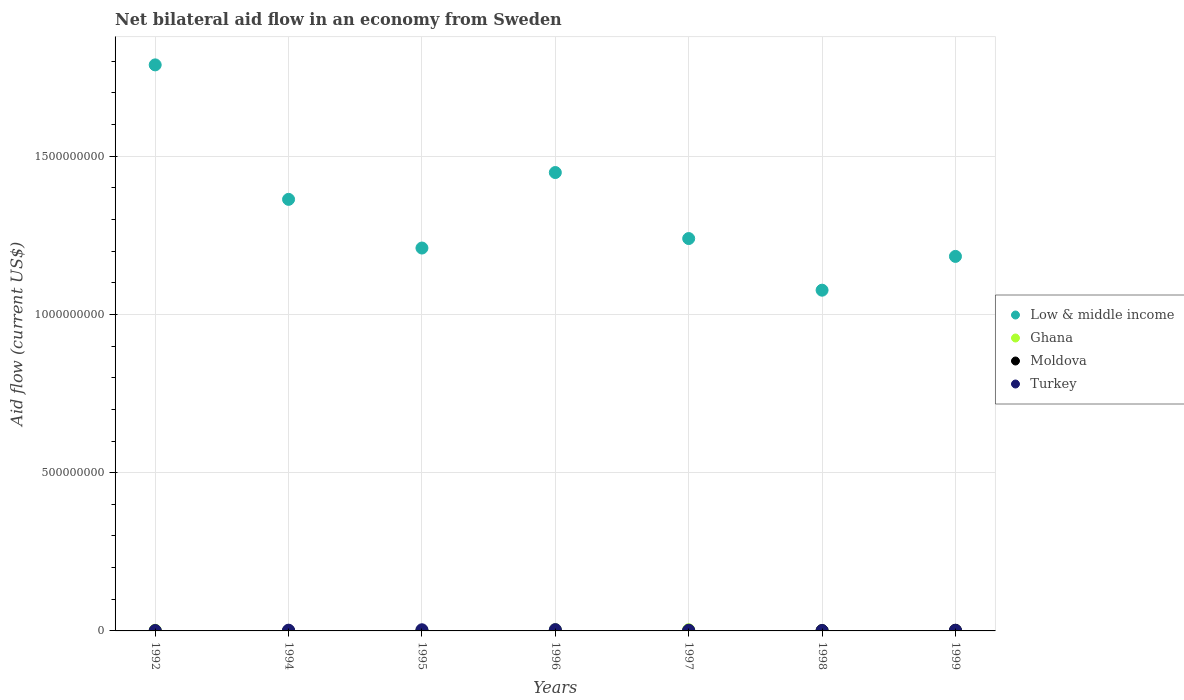How many different coloured dotlines are there?
Your response must be concise. 4. What is the net bilateral aid flow in Turkey in 1999?
Provide a succinct answer. 1.50e+06. Across all years, what is the maximum net bilateral aid flow in Moldova?
Offer a terse response. 2.19e+06. What is the total net bilateral aid flow in Moldova in the graph?
Your answer should be compact. 3.39e+06. What is the difference between the net bilateral aid flow in Turkey in 1994 and the net bilateral aid flow in Low & middle income in 1996?
Offer a terse response. -1.45e+09. What is the average net bilateral aid flow in Ghana per year?
Your answer should be very brief. 1.80e+06. In the year 1999, what is the difference between the net bilateral aid flow in Turkey and net bilateral aid flow in Low & middle income?
Your answer should be very brief. -1.18e+09. What is the ratio of the net bilateral aid flow in Turkey in 1992 to that in 1996?
Provide a succinct answer. 0.27. Is the net bilateral aid flow in Low & middle income in 1994 less than that in 1996?
Give a very brief answer. Yes. Is the difference between the net bilateral aid flow in Turkey in 1992 and 1995 greater than the difference between the net bilateral aid flow in Low & middle income in 1992 and 1995?
Ensure brevity in your answer.  No. What is the difference between the highest and the second highest net bilateral aid flow in Low & middle income?
Provide a short and direct response. 3.40e+08. What is the difference between the highest and the lowest net bilateral aid flow in Ghana?
Give a very brief answer. 3.42e+06. Is the net bilateral aid flow in Turkey strictly less than the net bilateral aid flow in Ghana over the years?
Provide a short and direct response. No. How many dotlines are there?
Make the answer very short. 4. What is the difference between two consecutive major ticks on the Y-axis?
Keep it short and to the point. 5.00e+08. Are the values on the major ticks of Y-axis written in scientific E-notation?
Your answer should be very brief. No. Does the graph contain any zero values?
Give a very brief answer. No. Does the graph contain grids?
Your answer should be very brief. Yes. How many legend labels are there?
Your response must be concise. 4. How are the legend labels stacked?
Give a very brief answer. Vertical. What is the title of the graph?
Offer a terse response. Net bilateral aid flow in an economy from Sweden. What is the Aid flow (current US$) of Low & middle income in 1992?
Make the answer very short. 1.79e+09. What is the Aid flow (current US$) in Ghana in 1992?
Your answer should be compact. 2.13e+06. What is the Aid flow (current US$) in Turkey in 1992?
Give a very brief answer. 1.15e+06. What is the Aid flow (current US$) in Low & middle income in 1994?
Keep it short and to the point. 1.36e+09. What is the Aid flow (current US$) in Ghana in 1994?
Provide a succinct answer. 4.30e+05. What is the Aid flow (current US$) in Moldova in 1994?
Ensure brevity in your answer.  10000. What is the Aid flow (current US$) of Turkey in 1994?
Ensure brevity in your answer.  2.35e+06. What is the Aid flow (current US$) in Low & middle income in 1995?
Your answer should be compact. 1.21e+09. What is the Aid flow (current US$) in Ghana in 1995?
Your answer should be very brief. 1.17e+06. What is the Aid flow (current US$) of Moldova in 1995?
Provide a succinct answer. 3.00e+04. What is the Aid flow (current US$) in Turkey in 1995?
Provide a short and direct response. 3.65e+06. What is the Aid flow (current US$) of Low & middle income in 1996?
Offer a terse response. 1.45e+09. What is the Aid flow (current US$) of Ghana in 1996?
Your answer should be compact. 3.85e+06. What is the Aid flow (current US$) in Turkey in 1996?
Your answer should be compact. 4.22e+06. What is the Aid flow (current US$) of Low & middle income in 1997?
Give a very brief answer. 1.24e+09. What is the Aid flow (current US$) in Ghana in 1997?
Keep it short and to the point. 3.76e+06. What is the Aid flow (current US$) in Moldova in 1997?
Provide a succinct answer. 9.00e+04. What is the Aid flow (current US$) in Turkey in 1997?
Your answer should be very brief. 2.24e+06. What is the Aid flow (current US$) in Low & middle income in 1998?
Your response must be concise. 1.08e+09. What is the Aid flow (current US$) in Ghana in 1998?
Ensure brevity in your answer.  6.50e+05. What is the Aid flow (current US$) of Moldova in 1998?
Keep it short and to the point. 9.60e+05. What is the Aid flow (current US$) of Turkey in 1998?
Make the answer very short. 9.50e+05. What is the Aid flow (current US$) in Low & middle income in 1999?
Your answer should be very brief. 1.18e+09. What is the Aid flow (current US$) of Ghana in 1999?
Provide a short and direct response. 5.80e+05. What is the Aid flow (current US$) in Moldova in 1999?
Provide a short and direct response. 2.19e+06. What is the Aid flow (current US$) in Turkey in 1999?
Ensure brevity in your answer.  1.50e+06. Across all years, what is the maximum Aid flow (current US$) in Low & middle income?
Your answer should be very brief. 1.79e+09. Across all years, what is the maximum Aid flow (current US$) of Ghana?
Your response must be concise. 3.85e+06. Across all years, what is the maximum Aid flow (current US$) in Moldova?
Offer a very short reply. 2.19e+06. Across all years, what is the maximum Aid flow (current US$) in Turkey?
Offer a terse response. 4.22e+06. Across all years, what is the minimum Aid flow (current US$) in Low & middle income?
Provide a succinct answer. 1.08e+09. Across all years, what is the minimum Aid flow (current US$) in Ghana?
Your answer should be very brief. 4.30e+05. Across all years, what is the minimum Aid flow (current US$) of Moldova?
Make the answer very short. 10000. Across all years, what is the minimum Aid flow (current US$) of Turkey?
Keep it short and to the point. 9.50e+05. What is the total Aid flow (current US$) of Low & middle income in the graph?
Your answer should be compact. 9.31e+09. What is the total Aid flow (current US$) in Ghana in the graph?
Offer a terse response. 1.26e+07. What is the total Aid flow (current US$) in Moldova in the graph?
Offer a terse response. 3.39e+06. What is the total Aid flow (current US$) in Turkey in the graph?
Provide a succinct answer. 1.61e+07. What is the difference between the Aid flow (current US$) in Low & middle income in 1992 and that in 1994?
Make the answer very short. 4.25e+08. What is the difference between the Aid flow (current US$) in Ghana in 1992 and that in 1994?
Ensure brevity in your answer.  1.70e+06. What is the difference between the Aid flow (current US$) in Moldova in 1992 and that in 1994?
Give a very brief answer. 9.00e+04. What is the difference between the Aid flow (current US$) of Turkey in 1992 and that in 1994?
Make the answer very short. -1.20e+06. What is the difference between the Aid flow (current US$) of Low & middle income in 1992 and that in 1995?
Your answer should be very brief. 5.79e+08. What is the difference between the Aid flow (current US$) of Ghana in 1992 and that in 1995?
Offer a terse response. 9.60e+05. What is the difference between the Aid flow (current US$) in Moldova in 1992 and that in 1995?
Provide a succinct answer. 7.00e+04. What is the difference between the Aid flow (current US$) in Turkey in 1992 and that in 1995?
Make the answer very short. -2.50e+06. What is the difference between the Aid flow (current US$) of Low & middle income in 1992 and that in 1996?
Offer a very short reply. 3.40e+08. What is the difference between the Aid flow (current US$) of Ghana in 1992 and that in 1996?
Ensure brevity in your answer.  -1.72e+06. What is the difference between the Aid flow (current US$) in Moldova in 1992 and that in 1996?
Offer a very short reply. 9.00e+04. What is the difference between the Aid flow (current US$) of Turkey in 1992 and that in 1996?
Provide a short and direct response. -3.07e+06. What is the difference between the Aid flow (current US$) in Low & middle income in 1992 and that in 1997?
Provide a short and direct response. 5.49e+08. What is the difference between the Aid flow (current US$) in Ghana in 1992 and that in 1997?
Ensure brevity in your answer.  -1.63e+06. What is the difference between the Aid flow (current US$) in Moldova in 1992 and that in 1997?
Offer a terse response. 10000. What is the difference between the Aid flow (current US$) in Turkey in 1992 and that in 1997?
Your response must be concise. -1.09e+06. What is the difference between the Aid flow (current US$) of Low & middle income in 1992 and that in 1998?
Keep it short and to the point. 7.12e+08. What is the difference between the Aid flow (current US$) in Ghana in 1992 and that in 1998?
Make the answer very short. 1.48e+06. What is the difference between the Aid flow (current US$) of Moldova in 1992 and that in 1998?
Offer a terse response. -8.60e+05. What is the difference between the Aid flow (current US$) of Turkey in 1992 and that in 1998?
Make the answer very short. 2.00e+05. What is the difference between the Aid flow (current US$) of Low & middle income in 1992 and that in 1999?
Provide a short and direct response. 6.05e+08. What is the difference between the Aid flow (current US$) in Ghana in 1992 and that in 1999?
Make the answer very short. 1.55e+06. What is the difference between the Aid flow (current US$) in Moldova in 1992 and that in 1999?
Your response must be concise. -2.09e+06. What is the difference between the Aid flow (current US$) of Turkey in 1992 and that in 1999?
Offer a terse response. -3.50e+05. What is the difference between the Aid flow (current US$) of Low & middle income in 1994 and that in 1995?
Make the answer very short. 1.54e+08. What is the difference between the Aid flow (current US$) in Ghana in 1994 and that in 1995?
Your response must be concise. -7.40e+05. What is the difference between the Aid flow (current US$) of Moldova in 1994 and that in 1995?
Give a very brief answer. -2.00e+04. What is the difference between the Aid flow (current US$) in Turkey in 1994 and that in 1995?
Provide a succinct answer. -1.30e+06. What is the difference between the Aid flow (current US$) of Low & middle income in 1994 and that in 1996?
Your answer should be compact. -8.48e+07. What is the difference between the Aid flow (current US$) in Ghana in 1994 and that in 1996?
Give a very brief answer. -3.42e+06. What is the difference between the Aid flow (current US$) in Turkey in 1994 and that in 1996?
Keep it short and to the point. -1.87e+06. What is the difference between the Aid flow (current US$) in Low & middle income in 1994 and that in 1997?
Your answer should be compact. 1.24e+08. What is the difference between the Aid flow (current US$) in Ghana in 1994 and that in 1997?
Your response must be concise. -3.33e+06. What is the difference between the Aid flow (current US$) of Turkey in 1994 and that in 1997?
Provide a short and direct response. 1.10e+05. What is the difference between the Aid flow (current US$) of Low & middle income in 1994 and that in 1998?
Provide a succinct answer. 2.87e+08. What is the difference between the Aid flow (current US$) in Ghana in 1994 and that in 1998?
Provide a short and direct response. -2.20e+05. What is the difference between the Aid flow (current US$) in Moldova in 1994 and that in 1998?
Keep it short and to the point. -9.50e+05. What is the difference between the Aid flow (current US$) of Turkey in 1994 and that in 1998?
Keep it short and to the point. 1.40e+06. What is the difference between the Aid flow (current US$) in Low & middle income in 1994 and that in 1999?
Offer a very short reply. 1.80e+08. What is the difference between the Aid flow (current US$) of Ghana in 1994 and that in 1999?
Make the answer very short. -1.50e+05. What is the difference between the Aid flow (current US$) in Moldova in 1994 and that in 1999?
Provide a succinct answer. -2.18e+06. What is the difference between the Aid flow (current US$) of Turkey in 1994 and that in 1999?
Your answer should be compact. 8.50e+05. What is the difference between the Aid flow (current US$) in Low & middle income in 1995 and that in 1996?
Give a very brief answer. -2.39e+08. What is the difference between the Aid flow (current US$) of Ghana in 1995 and that in 1996?
Give a very brief answer. -2.68e+06. What is the difference between the Aid flow (current US$) of Turkey in 1995 and that in 1996?
Your answer should be compact. -5.70e+05. What is the difference between the Aid flow (current US$) in Low & middle income in 1995 and that in 1997?
Offer a terse response. -3.00e+07. What is the difference between the Aid flow (current US$) in Ghana in 1995 and that in 1997?
Provide a short and direct response. -2.59e+06. What is the difference between the Aid flow (current US$) of Moldova in 1995 and that in 1997?
Provide a short and direct response. -6.00e+04. What is the difference between the Aid flow (current US$) of Turkey in 1995 and that in 1997?
Provide a short and direct response. 1.41e+06. What is the difference between the Aid flow (current US$) in Low & middle income in 1995 and that in 1998?
Give a very brief answer. 1.33e+08. What is the difference between the Aid flow (current US$) of Ghana in 1995 and that in 1998?
Your response must be concise. 5.20e+05. What is the difference between the Aid flow (current US$) of Moldova in 1995 and that in 1998?
Ensure brevity in your answer.  -9.30e+05. What is the difference between the Aid flow (current US$) in Turkey in 1995 and that in 1998?
Provide a short and direct response. 2.70e+06. What is the difference between the Aid flow (current US$) of Low & middle income in 1995 and that in 1999?
Ensure brevity in your answer.  2.64e+07. What is the difference between the Aid flow (current US$) in Ghana in 1995 and that in 1999?
Offer a terse response. 5.90e+05. What is the difference between the Aid flow (current US$) of Moldova in 1995 and that in 1999?
Provide a short and direct response. -2.16e+06. What is the difference between the Aid flow (current US$) of Turkey in 1995 and that in 1999?
Your response must be concise. 2.15e+06. What is the difference between the Aid flow (current US$) of Low & middle income in 1996 and that in 1997?
Keep it short and to the point. 2.09e+08. What is the difference between the Aid flow (current US$) in Turkey in 1996 and that in 1997?
Your answer should be very brief. 1.98e+06. What is the difference between the Aid flow (current US$) in Low & middle income in 1996 and that in 1998?
Ensure brevity in your answer.  3.72e+08. What is the difference between the Aid flow (current US$) of Ghana in 1996 and that in 1998?
Offer a terse response. 3.20e+06. What is the difference between the Aid flow (current US$) in Moldova in 1996 and that in 1998?
Your answer should be compact. -9.50e+05. What is the difference between the Aid flow (current US$) of Turkey in 1996 and that in 1998?
Offer a terse response. 3.27e+06. What is the difference between the Aid flow (current US$) in Low & middle income in 1996 and that in 1999?
Provide a short and direct response. 2.65e+08. What is the difference between the Aid flow (current US$) in Ghana in 1996 and that in 1999?
Keep it short and to the point. 3.27e+06. What is the difference between the Aid flow (current US$) in Moldova in 1996 and that in 1999?
Provide a short and direct response. -2.18e+06. What is the difference between the Aid flow (current US$) of Turkey in 1996 and that in 1999?
Offer a very short reply. 2.72e+06. What is the difference between the Aid flow (current US$) of Low & middle income in 1997 and that in 1998?
Offer a terse response. 1.63e+08. What is the difference between the Aid flow (current US$) in Ghana in 1997 and that in 1998?
Provide a short and direct response. 3.11e+06. What is the difference between the Aid flow (current US$) of Moldova in 1997 and that in 1998?
Offer a terse response. -8.70e+05. What is the difference between the Aid flow (current US$) in Turkey in 1997 and that in 1998?
Your answer should be compact. 1.29e+06. What is the difference between the Aid flow (current US$) of Low & middle income in 1997 and that in 1999?
Provide a short and direct response. 5.64e+07. What is the difference between the Aid flow (current US$) in Ghana in 1997 and that in 1999?
Give a very brief answer. 3.18e+06. What is the difference between the Aid flow (current US$) in Moldova in 1997 and that in 1999?
Give a very brief answer. -2.10e+06. What is the difference between the Aid flow (current US$) of Turkey in 1997 and that in 1999?
Offer a very short reply. 7.40e+05. What is the difference between the Aid flow (current US$) of Low & middle income in 1998 and that in 1999?
Keep it short and to the point. -1.07e+08. What is the difference between the Aid flow (current US$) of Ghana in 1998 and that in 1999?
Your answer should be compact. 7.00e+04. What is the difference between the Aid flow (current US$) of Moldova in 1998 and that in 1999?
Offer a very short reply. -1.23e+06. What is the difference between the Aid flow (current US$) in Turkey in 1998 and that in 1999?
Keep it short and to the point. -5.50e+05. What is the difference between the Aid flow (current US$) in Low & middle income in 1992 and the Aid flow (current US$) in Ghana in 1994?
Ensure brevity in your answer.  1.79e+09. What is the difference between the Aid flow (current US$) of Low & middle income in 1992 and the Aid flow (current US$) of Moldova in 1994?
Your response must be concise. 1.79e+09. What is the difference between the Aid flow (current US$) in Low & middle income in 1992 and the Aid flow (current US$) in Turkey in 1994?
Your answer should be compact. 1.79e+09. What is the difference between the Aid flow (current US$) in Ghana in 1992 and the Aid flow (current US$) in Moldova in 1994?
Ensure brevity in your answer.  2.12e+06. What is the difference between the Aid flow (current US$) in Moldova in 1992 and the Aid flow (current US$) in Turkey in 1994?
Give a very brief answer. -2.25e+06. What is the difference between the Aid flow (current US$) in Low & middle income in 1992 and the Aid flow (current US$) in Ghana in 1995?
Make the answer very short. 1.79e+09. What is the difference between the Aid flow (current US$) of Low & middle income in 1992 and the Aid flow (current US$) of Moldova in 1995?
Keep it short and to the point. 1.79e+09. What is the difference between the Aid flow (current US$) in Low & middle income in 1992 and the Aid flow (current US$) in Turkey in 1995?
Ensure brevity in your answer.  1.79e+09. What is the difference between the Aid flow (current US$) in Ghana in 1992 and the Aid flow (current US$) in Moldova in 1995?
Offer a terse response. 2.10e+06. What is the difference between the Aid flow (current US$) in Ghana in 1992 and the Aid flow (current US$) in Turkey in 1995?
Make the answer very short. -1.52e+06. What is the difference between the Aid flow (current US$) of Moldova in 1992 and the Aid flow (current US$) of Turkey in 1995?
Make the answer very short. -3.55e+06. What is the difference between the Aid flow (current US$) in Low & middle income in 1992 and the Aid flow (current US$) in Ghana in 1996?
Make the answer very short. 1.78e+09. What is the difference between the Aid flow (current US$) of Low & middle income in 1992 and the Aid flow (current US$) of Moldova in 1996?
Ensure brevity in your answer.  1.79e+09. What is the difference between the Aid flow (current US$) of Low & middle income in 1992 and the Aid flow (current US$) of Turkey in 1996?
Provide a short and direct response. 1.78e+09. What is the difference between the Aid flow (current US$) in Ghana in 1992 and the Aid flow (current US$) in Moldova in 1996?
Your response must be concise. 2.12e+06. What is the difference between the Aid flow (current US$) in Ghana in 1992 and the Aid flow (current US$) in Turkey in 1996?
Give a very brief answer. -2.09e+06. What is the difference between the Aid flow (current US$) in Moldova in 1992 and the Aid flow (current US$) in Turkey in 1996?
Provide a succinct answer. -4.12e+06. What is the difference between the Aid flow (current US$) of Low & middle income in 1992 and the Aid flow (current US$) of Ghana in 1997?
Your answer should be very brief. 1.79e+09. What is the difference between the Aid flow (current US$) of Low & middle income in 1992 and the Aid flow (current US$) of Moldova in 1997?
Give a very brief answer. 1.79e+09. What is the difference between the Aid flow (current US$) of Low & middle income in 1992 and the Aid flow (current US$) of Turkey in 1997?
Make the answer very short. 1.79e+09. What is the difference between the Aid flow (current US$) in Ghana in 1992 and the Aid flow (current US$) in Moldova in 1997?
Make the answer very short. 2.04e+06. What is the difference between the Aid flow (current US$) of Ghana in 1992 and the Aid flow (current US$) of Turkey in 1997?
Your answer should be very brief. -1.10e+05. What is the difference between the Aid flow (current US$) of Moldova in 1992 and the Aid flow (current US$) of Turkey in 1997?
Your answer should be compact. -2.14e+06. What is the difference between the Aid flow (current US$) in Low & middle income in 1992 and the Aid flow (current US$) in Ghana in 1998?
Your response must be concise. 1.79e+09. What is the difference between the Aid flow (current US$) in Low & middle income in 1992 and the Aid flow (current US$) in Moldova in 1998?
Provide a short and direct response. 1.79e+09. What is the difference between the Aid flow (current US$) in Low & middle income in 1992 and the Aid flow (current US$) in Turkey in 1998?
Give a very brief answer. 1.79e+09. What is the difference between the Aid flow (current US$) in Ghana in 1992 and the Aid flow (current US$) in Moldova in 1998?
Provide a short and direct response. 1.17e+06. What is the difference between the Aid flow (current US$) of Ghana in 1992 and the Aid flow (current US$) of Turkey in 1998?
Ensure brevity in your answer.  1.18e+06. What is the difference between the Aid flow (current US$) in Moldova in 1992 and the Aid flow (current US$) in Turkey in 1998?
Give a very brief answer. -8.50e+05. What is the difference between the Aid flow (current US$) in Low & middle income in 1992 and the Aid flow (current US$) in Ghana in 1999?
Offer a very short reply. 1.79e+09. What is the difference between the Aid flow (current US$) of Low & middle income in 1992 and the Aid flow (current US$) of Moldova in 1999?
Give a very brief answer. 1.79e+09. What is the difference between the Aid flow (current US$) of Low & middle income in 1992 and the Aid flow (current US$) of Turkey in 1999?
Make the answer very short. 1.79e+09. What is the difference between the Aid flow (current US$) of Ghana in 1992 and the Aid flow (current US$) of Turkey in 1999?
Offer a very short reply. 6.30e+05. What is the difference between the Aid flow (current US$) in Moldova in 1992 and the Aid flow (current US$) in Turkey in 1999?
Provide a succinct answer. -1.40e+06. What is the difference between the Aid flow (current US$) of Low & middle income in 1994 and the Aid flow (current US$) of Ghana in 1995?
Keep it short and to the point. 1.36e+09. What is the difference between the Aid flow (current US$) in Low & middle income in 1994 and the Aid flow (current US$) in Moldova in 1995?
Ensure brevity in your answer.  1.36e+09. What is the difference between the Aid flow (current US$) of Low & middle income in 1994 and the Aid flow (current US$) of Turkey in 1995?
Offer a terse response. 1.36e+09. What is the difference between the Aid flow (current US$) of Ghana in 1994 and the Aid flow (current US$) of Turkey in 1995?
Offer a terse response. -3.22e+06. What is the difference between the Aid flow (current US$) of Moldova in 1994 and the Aid flow (current US$) of Turkey in 1995?
Offer a very short reply. -3.64e+06. What is the difference between the Aid flow (current US$) of Low & middle income in 1994 and the Aid flow (current US$) of Ghana in 1996?
Provide a succinct answer. 1.36e+09. What is the difference between the Aid flow (current US$) in Low & middle income in 1994 and the Aid flow (current US$) in Moldova in 1996?
Provide a succinct answer. 1.36e+09. What is the difference between the Aid flow (current US$) of Low & middle income in 1994 and the Aid flow (current US$) of Turkey in 1996?
Your answer should be compact. 1.36e+09. What is the difference between the Aid flow (current US$) of Ghana in 1994 and the Aid flow (current US$) of Moldova in 1996?
Offer a terse response. 4.20e+05. What is the difference between the Aid flow (current US$) in Ghana in 1994 and the Aid flow (current US$) in Turkey in 1996?
Give a very brief answer. -3.79e+06. What is the difference between the Aid flow (current US$) in Moldova in 1994 and the Aid flow (current US$) in Turkey in 1996?
Give a very brief answer. -4.21e+06. What is the difference between the Aid flow (current US$) in Low & middle income in 1994 and the Aid flow (current US$) in Ghana in 1997?
Provide a succinct answer. 1.36e+09. What is the difference between the Aid flow (current US$) of Low & middle income in 1994 and the Aid flow (current US$) of Moldova in 1997?
Provide a short and direct response. 1.36e+09. What is the difference between the Aid flow (current US$) of Low & middle income in 1994 and the Aid flow (current US$) of Turkey in 1997?
Offer a very short reply. 1.36e+09. What is the difference between the Aid flow (current US$) in Ghana in 1994 and the Aid flow (current US$) in Turkey in 1997?
Offer a very short reply. -1.81e+06. What is the difference between the Aid flow (current US$) of Moldova in 1994 and the Aid flow (current US$) of Turkey in 1997?
Give a very brief answer. -2.23e+06. What is the difference between the Aid flow (current US$) of Low & middle income in 1994 and the Aid flow (current US$) of Ghana in 1998?
Offer a terse response. 1.36e+09. What is the difference between the Aid flow (current US$) in Low & middle income in 1994 and the Aid flow (current US$) in Moldova in 1998?
Make the answer very short. 1.36e+09. What is the difference between the Aid flow (current US$) of Low & middle income in 1994 and the Aid flow (current US$) of Turkey in 1998?
Offer a terse response. 1.36e+09. What is the difference between the Aid flow (current US$) in Ghana in 1994 and the Aid flow (current US$) in Moldova in 1998?
Your answer should be compact. -5.30e+05. What is the difference between the Aid flow (current US$) of Ghana in 1994 and the Aid flow (current US$) of Turkey in 1998?
Provide a short and direct response. -5.20e+05. What is the difference between the Aid flow (current US$) in Moldova in 1994 and the Aid flow (current US$) in Turkey in 1998?
Provide a succinct answer. -9.40e+05. What is the difference between the Aid flow (current US$) of Low & middle income in 1994 and the Aid flow (current US$) of Ghana in 1999?
Ensure brevity in your answer.  1.36e+09. What is the difference between the Aid flow (current US$) of Low & middle income in 1994 and the Aid flow (current US$) of Moldova in 1999?
Your response must be concise. 1.36e+09. What is the difference between the Aid flow (current US$) of Low & middle income in 1994 and the Aid flow (current US$) of Turkey in 1999?
Offer a very short reply. 1.36e+09. What is the difference between the Aid flow (current US$) of Ghana in 1994 and the Aid flow (current US$) of Moldova in 1999?
Ensure brevity in your answer.  -1.76e+06. What is the difference between the Aid flow (current US$) in Ghana in 1994 and the Aid flow (current US$) in Turkey in 1999?
Ensure brevity in your answer.  -1.07e+06. What is the difference between the Aid flow (current US$) of Moldova in 1994 and the Aid flow (current US$) of Turkey in 1999?
Your answer should be compact. -1.49e+06. What is the difference between the Aid flow (current US$) in Low & middle income in 1995 and the Aid flow (current US$) in Ghana in 1996?
Give a very brief answer. 1.21e+09. What is the difference between the Aid flow (current US$) in Low & middle income in 1995 and the Aid flow (current US$) in Moldova in 1996?
Offer a terse response. 1.21e+09. What is the difference between the Aid flow (current US$) of Low & middle income in 1995 and the Aid flow (current US$) of Turkey in 1996?
Give a very brief answer. 1.21e+09. What is the difference between the Aid flow (current US$) of Ghana in 1995 and the Aid flow (current US$) of Moldova in 1996?
Keep it short and to the point. 1.16e+06. What is the difference between the Aid flow (current US$) of Ghana in 1995 and the Aid flow (current US$) of Turkey in 1996?
Provide a succinct answer. -3.05e+06. What is the difference between the Aid flow (current US$) of Moldova in 1995 and the Aid flow (current US$) of Turkey in 1996?
Your response must be concise. -4.19e+06. What is the difference between the Aid flow (current US$) of Low & middle income in 1995 and the Aid flow (current US$) of Ghana in 1997?
Your answer should be compact. 1.21e+09. What is the difference between the Aid flow (current US$) of Low & middle income in 1995 and the Aid flow (current US$) of Moldova in 1997?
Make the answer very short. 1.21e+09. What is the difference between the Aid flow (current US$) of Low & middle income in 1995 and the Aid flow (current US$) of Turkey in 1997?
Your response must be concise. 1.21e+09. What is the difference between the Aid flow (current US$) in Ghana in 1995 and the Aid flow (current US$) in Moldova in 1997?
Offer a terse response. 1.08e+06. What is the difference between the Aid flow (current US$) in Ghana in 1995 and the Aid flow (current US$) in Turkey in 1997?
Make the answer very short. -1.07e+06. What is the difference between the Aid flow (current US$) of Moldova in 1995 and the Aid flow (current US$) of Turkey in 1997?
Provide a short and direct response. -2.21e+06. What is the difference between the Aid flow (current US$) of Low & middle income in 1995 and the Aid flow (current US$) of Ghana in 1998?
Ensure brevity in your answer.  1.21e+09. What is the difference between the Aid flow (current US$) of Low & middle income in 1995 and the Aid flow (current US$) of Moldova in 1998?
Give a very brief answer. 1.21e+09. What is the difference between the Aid flow (current US$) of Low & middle income in 1995 and the Aid flow (current US$) of Turkey in 1998?
Your answer should be very brief. 1.21e+09. What is the difference between the Aid flow (current US$) of Ghana in 1995 and the Aid flow (current US$) of Moldova in 1998?
Offer a very short reply. 2.10e+05. What is the difference between the Aid flow (current US$) in Ghana in 1995 and the Aid flow (current US$) in Turkey in 1998?
Provide a short and direct response. 2.20e+05. What is the difference between the Aid flow (current US$) of Moldova in 1995 and the Aid flow (current US$) of Turkey in 1998?
Offer a terse response. -9.20e+05. What is the difference between the Aid flow (current US$) of Low & middle income in 1995 and the Aid flow (current US$) of Ghana in 1999?
Your answer should be very brief. 1.21e+09. What is the difference between the Aid flow (current US$) of Low & middle income in 1995 and the Aid flow (current US$) of Moldova in 1999?
Your answer should be very brief. 1.21e+09. What is the difference between the Aid flow (current US$) of Low & middle income in 1995 and the Aid flow (current US$) of Turkey in 1999?
Your answer should be compact. 1.21e+09. What is the difference between the Aid flow (current US$) of Ghana in 1995 and the Aid flow (current US$) of Moldova in 1999?
Ensure brevity in your answer.  -1.02e+06. What is the difference between the Aid flow (current US$) in Ghana in 1995 and the Aid flow (current US$) in Turkey in 1999?
Offer a terse response. -3.30e+05. What is the difference between the Aid flow (current US$) in Moldova in 1995 and the Aid flow (current US$) in Turkey in 1999?
Make the answer very short. -1.47e+06. What is the difference between the Aid flow (current US$) in Low & middle income in 1996 and the Aid flow (current US$) in Ghana in 1997?
Keep it short and to the point. 1.44e+09. What is the difference between the Aid flow (current US$) in Low & middle income in 1996 and the Aid flow (current US$) in Moldova in 1997?
Give a very brief answer. 1.45e+09. What is the difference between the Aid flow (current US$) of Low & middle income in 1996 and the Aid flow (current US$) of Turkey in 1997?
Your answer should be compact. 1.45e+09. What is the difference between the Aid flow (current US$) of Ghana in 1996 and the Aid flow (current US$) of Moldova in 1997?
Make the answer very short. 3.76e+06. What is the difference between the Aid flow (current US$) in Ghana in 1996 and the Aid flow (current US$) in Turkey in 1997?
Provide a short and direct response. 1.61e+06. What is the difference between the Aid flow (current US$) of Moldova in 1996 and the Aid flow (current US$) of Turkey in 1997?
Give a very brief answer. -2.23e+06. What is the difference between the Aid flow (current US$) in Low & middle income in 1996 and the Aid flow (current US$) in Ghana in 1998?
Keep it short and to the point. 1.45e+09. What is the difference between the Aid flow (current US$) in Low & middle income in 1996 and the Aid flow (current US$) in Moldova in 1998?
Offer a very short reply. 1.45e+09. What is the difference between the Aid flow (current US$) of Low & middle income in 1996 and the Aid flow (current US$) of Turkey in 1998?
Make the answer very short. 1.45e+09. What is the difference between the Aid flow (current US$) in Ghana in 1996 and the Aid flow (current US$) in Moldova in 1998?
Make the answer very short. 2.89e+06. What is the difference between the Aid flow (current US$) of Ghana in 1996 and the Aid flow (current US$) of Turkey in 1998?
Provide a succinct answer. 2.90e+06. What is the difference between the Aid flow (current US$) in Moldova in 1996 and the Aid flow (current US$) in Turkey in 1998?
Offer a very short reply. -9.40e+05. What is the difference between the Aid flow (current US$) in Low & middle income in 1996 and the Aid flow (current US$) in Ghana in 1999?
Make the answer very short. 1.45e+09. What is the difference between the Aid flow (current US$) of Low & middle income in 1996 and the Aid flow (current US$) of Moldova in 1999?
Your answer should be compact. 1.45e+09. What is the difference between the Aid flow (current US$) in Low & middle income in 1996 and the Aid flow (current US$) in Turkey in 1999?
Keep it short and to the point. 1.45e+09. What is the difference between the Aid flow (current US$) of Ghana in 1996 and the Aid flow (current US$) of Moldova in 1999?
Keep it short and to the point. 1.66e+06. What is the difference between the Aid flow (current US$) in Ghana in 1996 and the Aid flow (current US$) in Turkey in 1999?
Provide a short and direct response. 2.35e+06. What is the difference between the Aid flow (current US$) in Moldova in 1996 and the Aid flow (current US$) in Turkey in 1999?
Give a very brief answer. -1.49e+06. What is the difference between the Aid flow (current US$) in Low & middle income in 1997 and the Aid flow (current US$) in Ghana in 1998?
Your answer should be compact. 1.24e+09. What is the difference between the Aid flow (current US$) of Low & middle income in 1997 and the Aid flow (current US$) of Moldova in 1998?
Your answer should be very brief. 1.24e+09. What is the difference between the Aid flow (current US$) of Low & middle income in 1997 and the Aid flow (current US$) of Turkey in 1998?
Ensure brevity in your answer.  1.24e+09. What is the difference between the Aid flow (current US$) of Ghana in 1997 and the Aid flow (current US$) of Moldova in 1998?
Keep it short and to the point. 2.80e+06. What is the difference between the Aid flow (current US$) of Ghana in 1997 and the Aid flow (current US$) of Turkey in 1998?
Your response must be concise. 2.81e+06. What is the difference between the Aid flow (current US$) of Moldova in 1997 and the Aid flow (current US$) of Turkey in 1998?
Provide a succinct answer. -8.60e+05. What is the difference between the Aid flow (current US$) in Low & middle income in 1997 and the Aid flow (current US$) in Ghana in 1999?
Provide a short and direct response. 1.24e+09. What is the difference between the Aid flow (current US$) in Low & middle income in 1997 and the Aid flow (current US$) in Moldova in 1999?
Keep it short and to the point. 1.24e+09. What is the difference between the Aid flow (current US$) of Low & middle income in 1997 and the Aid flow (current US$) of Turkey in 1999?
Your answer should be very brief. 1.24e+09. What is the difference between the Aid flow (current US$) in Ghana in 1997 and the Aid flow (current US$) in Moldova in 1999?
Offer a terse response. 1.57e+06. What is the difference between the Aid flow (current US$) in Ghana in 1997 and the Aid flow (current US$) in Turkey in 1999?
Provide a short and direct response. 2.26e+06. What is the difference between the Aid flow (current US$) of Moldova in 1997 and the Aid flow (current US$) of Turkey in 1999?
Provide a short and direct response. -1.41e+06. What is the difference between the Aid flow (current US$) of Low & middle income in 1998 and the Aid flow (current US$) of Ghana in 1999?
Provide a succinct answer. 1.08e+09. What is the difference between the Aid flow (current US$) in Low & middle income in 1998 and the Aid flow (current US$) in Moldova in 1999?
Your response must be concise. 1.07e+09. What is the difference between the Aid flow (current US$) of Low & middle income in 1998 and the Aid flow (current US$) of Turkey in 1999?
Make the answer very short. 1.08e+09. What is the difference between the Aid flow (current US$) in Ghana in 1998 and the Aid flow (current US$) in Moldova in 1999?
Your answer should be compact. -1.54e+06. What is the difference between the Aid flow (current US$) in Ghana in 1998 and the Aid flow (current US$) in Turkey in 1999?
Make the answer very short. -8.50e+05. What is the difference between the Aid flow (current US$) of Moldova in 1998 and the Aid flow (current US$) of Turkey in 1999?
Your answer should be compact. -5.40e+05. What is the average Aid flow (current US$) in Low & middle income per year?
Your response must be concise. 1.33e+09. What is the average Aid flow (current US$) in Ghana per year?
Provide a succinct answer. 1.80e+06. What is the average Aid flow (current US$) of Moldova per year?
Your answer should be compact. 4.84e+05. What is the average Aid flow (current US$) of Turkey per year?
Your answer should be compact. 2.29e+06. In the year 1992, what is the difference between the Aid flow (current US$) in Low & middle income and Aid flow (current US$) in Ghana?
Your answer should be compact. 1.79e+09. In the year 1992, what is the difference between the Aid flow (current US$) of Low & middle income and Aid flow (current US$) of Moldova?
Ensure brevity in your answer.  1.79e+09. In the year 1992, what is the difference between the Aid flow (current US$) in Low & middle income and Aid flow (current US$) in Turkey?
Give a very brief answer. 1.79e+09. In the year 1992, what is the difference between the Aid flow (current US$) of Ghana and Aid flow (current US$) of Moldova?
Your response must be concise. 2.03e+06. In the year 1992, what is the difference between the Aid flow (current US$) of Ghana and Aid flow (current US$) of Turkey?
Provide a succinct answer. 9.80e+05. In the year 1992, what is the difference between the Aid flow (current US$) of Moldova and Aid flow (current US$) of Turkey?
Your response must be concise. -1.05e+06. In the year 1994, what is the difference between the Aid flow (current US$) of Low & middle income and Aid flow (current US$) of Ghana?
Your answer should be very brief. 1.36e+09. In the year 1994, what is the difference between the Aid flow (current US$) of Low & middle income and Aid flow (current US$) of Moldova?
Your response must be concise. 1.36e+09. In the year 1994, what is the difference between the Aid flow (current US$) of Low & middle income and Aid flow (current US$) of Turkey?
Provide a short and direct response. 1.36e+09. In the year 1994, what is the difference between the Aid flow (current US$) in Ghana and Aid flow (current US$) in Turkey?
Make the answer very short. -1.92e+06. In the year 1994, what is the difference between the Aid flow (current US$) of Moldova and Aid flow (current US$) of Turkey?
Give a very brief answer. -2.34e+06. In the year 1995, what is the difference between the Aid flow (current US$) of Low & middle income and Aid flow (current US$) of Ghana?
Your answer should be compact. 1.21e+09. In the year 1995, what is the difference between the Aid flow (current US$) of Low & middle income and Aid flow (current US$) of Moldova?
Ensure brevity in your answer.  1.21e+09. In the year 1995, what is the difference between the Aid flow (current US$) of Low & middle income and Aid flow (current US$) of Turkey?
Make the answer very short. 1.21e+09. In the year 1995, what is the difference between the Aid flow (current US$) in Ghana and Aid flow (current US$) in Moldova?
Provide a succinct answer. 1.14e+06. In the year 1995, what is the difference between the Aid flow (current US$) in Ghana and Aid flow (current US$) in Turkey?
Ensure brevity in your answer.  -2.48e+06. In the year 1995, what is the difference between the Aid flow (current US$) in Moldova and Aid flow (current US$) in Turkey?
Your answer should be compact. -3.62e+06. In the year 1996, what is the difference between the Aid flow (current US$) in Low & middle income and Aid flow (current US$) in Ghana?
Provide a succinct answer. 1.44e+09. In the year 1996, what is the difference between the Aid flow (current US$) in Low & middle income and Aid flow (current US$) in Moldova?
Offer a very short reply. 1.45e+09. In the year 1996, what is the difference between the Aid flow (current US$) of Low & middle income and Aid flow (current US$) of Turkey?
Your answer should be compact. 1.44e+09. In the year 1996, what is the difference between the Aid flow (current US$) of Ghana and Aid flow (current US$) of Moldova?
Keep it short and to the point. 3.84e+06. In the year 1996, what is the difference between the Aid flow (current US$) in Ghana and Aid flow (current US$) in Turkey?
Your answer should be compact. -3.70e+05. In the year 1996, what is the difference between the Aid flow (current US$) in Moldova and Aid flow (current US$) in Turkey?
Your answer should be compact. -4.21e+06. In the year 1997, what is the difference between the Aid flow (current US$) of Low & middle income and Aid flow (current US$) of Ghana?
Give a very brief answer. 1.24e+09. In the year 1997, what is the difference between the Aid flow (current US$) of Low & middle income and Aid flow (current US$) of Moldova?
Provide a succinct answer. 1.24e+09. In the year 1997, what is the difference between the Aid flow (current US$) of Low & middle income and Aid flow (current US$) of Turkey?
Offer a very short reply. 1.24e+09. In the year 1997, what is the difference between the Aid flow (current US$) in Ghana and Aid flow (current US$) in Moldova?
Your answer should be very brief. 3.67e+06. In the year 1997, what is the difference between the Aid flow (current US$) in Ghana and Aid flow (current US$) in Turkey?
Offer a very short reply. 1.52e+06. In the year 1997, what is the difference between the Aid flow (current US$) in Moldova and Aid flow (current US$) in Turkey?
Make the answer very short. -2.15e+06. In the year 1998, what is the difference between the Aid flow (current US$) of Low & middle income and Aid flow (current US$) of Ghana?
Your answer should be compact. 1.08e+09. In the year 1998, what is the difference between the Aid flow (current US$) of Low & middle income and Aid flow (current US$) of Moldova?
Provide a short and direct response. 1.08e+09. In the year 1998, what is the difference between the Aid flow (current US$) of Low & middle income and Aid flow (current US$) of Turkey?
Your answer should be compact. 1.08e+09. In the year 1998, what is the difference between the Aid flow (current US$) of Ghana and Aid flow (current US$) of Moldova?
Provide a short and direct response. -3.10e+05. In the year 1998, what is the difference between the Aid flow (current US$) in Ghana and Aid flow (current US$) in Turkey?
Ensure brevity in your answer.  -3.00e+05. In the year 1999, what is the difference between the Aid flow (current US$) of Low & middle income and Aid flow (current US$) of Ghana?
Ensure brevity in your answer.  1.18e+09. In the year 1999, what is the difference between the Aid flow (current US$) in Low & middle income and Aid flow (current US$) in Moldova?
Make the answer very short. 1.18e+09. In the year 1999, what is the difference between the Aid flow (current US$) of Low & middle income and Aid flow (current US$) of Turkey?
Your answer should be very brief. 1.18e+09. In the year 1999, what is the difference between the Aid flow (current US$) in Ghana and Aid flow (current US$) in Moldova?
Keep it short and to the point. -1.61e+06. In the year 1999, what is the difference between the Aid flow (current US$) in Ghana and Aid flow (current US$) in Turkey?
Provide a succinct answer. -9.20e+05. In the year 1999, what is the difference between the Aid flow (current US$) of Moldova and Aid flow (current US$) of Turkey?
Offer a terse response. 6.90e+05. What is the ratio of the Aid flow (current US$) of Low & middle income in 1992 to that in 1994?
Provide a short and direct response. 1.31. What is the ratio of the Aid flow (current US$) of Ghana in 1992 to that in 1994?
Give a very brief answer. 4.95. What is the ratio of the Aid flow (current US$) of Turkey in 1992 to that in 1994?
Make the answer very short. 0.49. What is the ratio of the Aid flow (current US$) of Low & middle income in 1992 to that in 1995?
Offer a terse response. 1.48. What is the ratio of the Aid flow (current US$) in Ghana in 1992 to that in 1995?
Offer a terse response. 1.82. What is the ratio of the Aid flow (current US$) of Moldova in 1992 to that in 1995?
Make the answer very short. 3.33. What is the ratio of the Aid flow (current US$) of Turkey in 1992 to that in 1995?
Your answer should be very brief. 0.32. What is the ratio of the Aid flow (current US$) in Low & middle income in 1992 to that in 1996?
Provide a succinct answer. 1.23. What is the ratio of the Aid flow (current US$) in Ghana in 1992 to that in 1996?
Offer a terse response. 0.55. What is the ratio of the Aid flow (current US$) of Moldova in 1992 to that in 1996?
Offer a very short reply. 10. What is the ratio of the Aid flow (current US$) of Turkey in 1992 to that in 1996?
Keep it short and to the point. 0.27. What is the ratio of the Aid flow (current US$) of Low & middle income in 1992 to that in 1997?
Provide a short and direct response. 1.44. What is the ratio of the Aid flow (current US$) of Ghana in 1992 to that in 1997?
Your answer should be compact. 0.57. What is the ratio of the Aid flow (current US$) of Turkey in 1992 to that in 1997?
Give a very brief answer. 0.51. What is the ratio of the Aid flow (current US$) of Low & middle income in 1992 to that in 1998?
Provide a succinct answer. 1.66. What is the ratio of the Aid flow (current US$) of Ghana in 1992 to that in 1998?
Your answer should be compact. 3.28. What is the ratio of the Aid flow (current US$) in Moldova in 1992 to that in 1998?
Make the answer very short. 0.1. What is the ratio of the Aid flow (current US$) in Turkey in 1992 to that in 1998?
Provide a succinct answer. 1.21. What is the ratio of the Aid flow (current US$) in Low & middle income in 1992 to that in 1999?
Ensure brevity in your answer.  1.51. What is the ratio of the Aid flow (current US$) in Ghana in 1992 to that in 1999?
Your response must be concise. 3.67. What is the ratio of the Aid flow (current US$) of Moldova in 1992 to that in 1999?
Your response must be concise. 0.05. What is the ratio of the Aid flow (current US$) in Turkey in 1992 to that in 1999?
Your answer should be compact. 0.77. What is the ratio of the Aid flow (current US$) of Low & middle income in 1994 to that in 1995?
Offer a very short reply. 1.13. What is the ratio of the Aid flow (current US$) in Ghana in 1994 to that in 1995?
Your answer should be compact. 0.37. What is the ratio of the Aid flow (current US$) of Moldova in 1994 to that in 1995?
Your answer should be very brief. 0.33. What is the ratio of the Aid flow (current US$) in Turkey in 1994 to that in 1995?
Provide a succinct answer. 0.64. What is the ratio of the Aid flow (current US$) in Low & middle income in 1994 to that in 1996?
Provide a short and direct response. 0.94. What is the ratio of the Aid flow (current US$) in Ghana in 1994 to that in 1996?
Make the answer very short. 0.11. What is the ratio of the Aid flow (current US$) of Moldova in 1994 to that in 1996?
Provide a succinct answer. 1. What is the ratio of the Aid flow (current US$) in Turkey in 1994 to that in 1996?
Give a very brief answer. 0.56. What is the ratio of the Aid flow (current US$) in Low & middle income in 1994 to that in 1997?
Your response must be concise. 1.1. What is the ratio of the Aid flow (current US$) in Ghana in 1994 to that in 1997?
Offer a terse response. 0.11. What is the ratio of the Aid flow (current US$) of Turkey in 1994 to that in 1997?
Offer a terse response. 1.05. What is the ratio of the Aid flow (current US$) in Low & middle income in 1994 to that in 1998?
Keep it short and to the point. 1.27. What is the ratio of the Aid flow (current US$) of Ghana in 1994 to that in 1998?
Give a very brief answer. 0.66. What is the ratio of the Aid flow (current US$) in Moldova in 1994 to that in 1998?
Provide a short and direct response. 0.01. What is the ratio of the Aid flow (current US$) in Turkey in 1994 to that in 1998?
Your answer should be very brief. 2.47. What is the ratio of the Aid flow (current US$) in Low & middle income in 1994 to that in 1999?
Your answer should be very brief. 1.15. What is the ratio of the Aid flow (current US$) in Ghana in 1994 to that in 1999?
Your answer should be compact. 0.74. What is the ratio of the Aid flow (current US$) in Moldova in 1994 to that in 1999?
Your answer should be very brief. 0. What is the ratio of the Aid flow (current US$) in Turkey in 1994 to that in 1999?
Keep it short and to the point. 1.57. What is the ratio of the Aid flow (current US$) of Low & middle income in 1995 to that in 1996?
Ensure brevity in your answer.  0.84. What is the ratio of the Aid flow (current US$) in Ghana in 1995 to that in 1996?
Provide a succinct answer. 0.3. What is the ratio of the Aid flow (current US$) in Turkey in 1995 to that in 1996?
Make the answer very short. 0.86. What is the ratio of the Aid flow (current US$) of Low & middle income in 1995 to that in 1997?
Offer a very short reply. 0.98. What is the ratio of the Aid flow (current US$) of Ghana in 1995 to that in 1997?
Offer a very short reply. 0.31. What is the ratio of the Aid flow (current US$) in Turkey in 1995 to that in 1997?
Ensure brevity in your answer.  1.63. What is the ratio of the Aid flow (current US$) of Low & middle income in 1995 to that in 1998?
Provide a short and direct response. 1.12. What is the ratio of the Aid flow (current US$) of Moldova in 1995 to that in 1998?
Your answer should be compact. 0.03. What is the ratio of the Aid flow (current US$) of Turkey in 1995 to that in 1998?
Provide a succinct answer. 3.84. What is the ratio of the Aid flow (current US$) of Low & middle income in 1995 to that in 1999?
Provide a short and direct response. 1.02. What is the ratio of the Aid flow (current US$) in Ghana in 1995 to that in 1999?
Provide a short and direct response. 2.02. What is the ratio of the Aid flow (current US$) in Moldova in 1995 to that in 1999?
Provide a succinct answer. 0.01. What is the ratio of the Aid flow (current US$) of Turkey in 1995 to that in 1999?
Offer a very short reply. 2.43. What is the ratio of the Aid flow (current US$) in Low & middle income in 1996 to that in 1997?
Ensure brevity in your answer.  1.17. What is the ratio of the Aid flow (current US$) of Ghana in 1996 to that in 1997?
Provide a short and direct response. 1.02. What is the ratio of the Aid flow (current US$) in Turkey in 1996 to that in 1997?
Your answer should be compact. 1.88. What is the ratio of the Aid flow (current US$) of Low & middle income in 1996 to that in 1998?
Offer a terse response. 1.35. What is the ratio of the Aid flow (current US$) in Ghana in 1996 to that in 1998?
Your answer should be compact. 5.92. What is the ratio of the Aid flow (current US$) in Moldova in 1996 to that in 1998?
Your response must be concise. 0.01. What is the ratio of the Aid flow (current US$) in Turkey in 1996 to that in 1998?
Your answer should be compact. 4.44. What is the ratio of the Aid flow (current US$) of Low & middle income in 1996 to that in 1999?
Your answer should be very brief. 1.22. What is the ratio of the Aid flow (current US$) in Ghana in 1996 to that in 1999?
Give a very brief answer. 6.64. What is the ratio of the Aid flow (current US$) in Moldova in 1996 to that in 1999?
Give a very brief answer. 0. What is the ratio of the Aid flow (current US$) in Turkey in 1996 to that in 1999?
Offer a terse response. 2.81. What is the ratio of the Aid flow (current US$) in Low & middle income in 1997 to that in 1998?
Give a very brief answer. 1.15. What is the ratio of the Aid flow (current US$) in Ghana in 1997 to that in 1998?
Offer a terse response. 5.78. What is the ratio of the Aid flow (current US$) in Moldova in 1997 to that in 1998?
Offer a very short reply. 0.09. What is the ratio of the Aid flow (current US$) in Turkey in 1997 to that in 1998?
Your answer should be very brief. 2.36. What is the ratio of the Aid flow (current US$) of Low & middle income in 1997 to that in 1999?
Give a very brief answer. 1.05. What is the ratio of the Aid flow (current US$) in Ghana in 1997 to that in 1999?
Offer a terse response. 6.48. What is the ratio of the Aid flow (current US$) of Moldova in 1997 to that in 1999?
Offer a very short reply. 0.04. What is the ratio of the Aid flow (current US$) in Turkey in 1997 to that in 1999?
Offer a very short reply. 1.49. What is the ratio of the Aid flow (current US$) in Low & middle income in 1998 to that in 1999?
Your answer should be compact. 0.91. What is the ratio of the Aid flow (current US$) in Ghana in 1998 to that in 1999?
Make the answer very short. 1.12. What is the ratio of the Aid flow (current US$) of Moldova in 1998 to that in 1999?
Your response must be concise. 0.44. What is the ratio of the Aid flow (current US$) in Turkey in 1998 to that in 1999?
Offer a very short reply. 0.63. What is the difference between the highest and the second highest Aid flow (current US$) of Low & middle income?
Offer a very short reply. 3.40e+08. What is the difference between the highest and the second highest Aid flow (current US$) in Moldova?
Your answer should be very brief. 1.23e+06. What is the difference between the highest and the second highest Aid flow (current US$) in Turkey?
Offer a very short reply. 5.70e+05. What is the difference between the highest and the lowest Aid flow (current US$) of Low & middle income?
Keep it short and to the point. 7.12e+08. What is the difference between the highest and the lowest Aid flow (current US$) of Ghana?
Keep it short and to the point. 3.42e+06. What is the difference between the highest and the lowest Aid flow (current US$) of Moldova?
Keep it short and to the point. 2.18e+06. What is the difference between the highest and the lowest Aid flow (current US$) in Turkey?
Ensure brevity in your answer.  3.27e+06. 